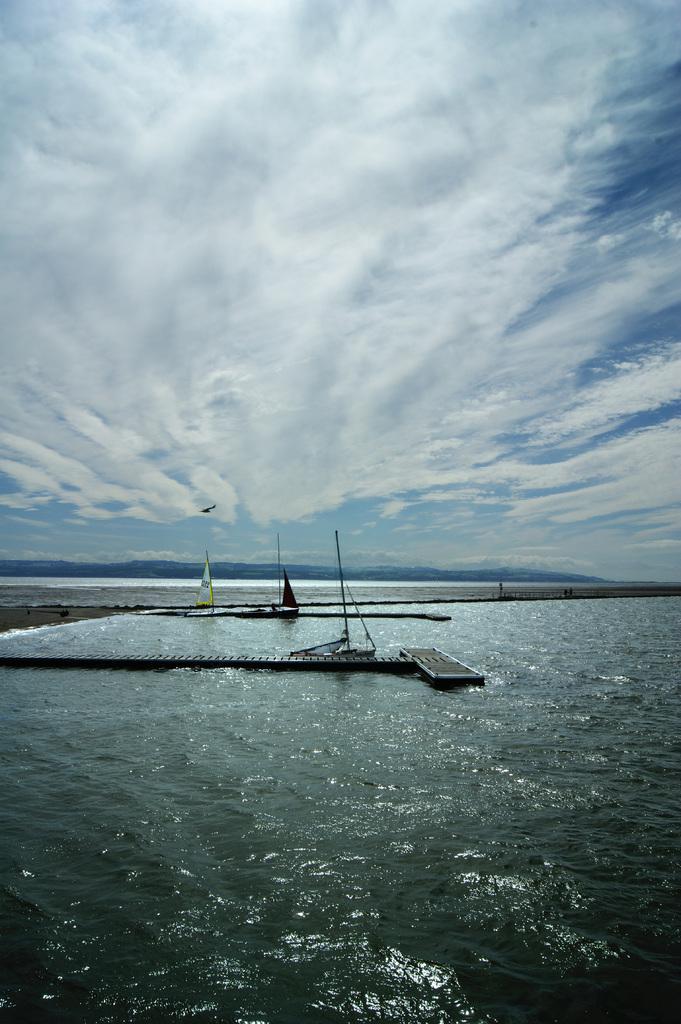Could you give a brief overview of what you see in this image? In this image I see the water and I see the platform over here. In the background I see the sky. 